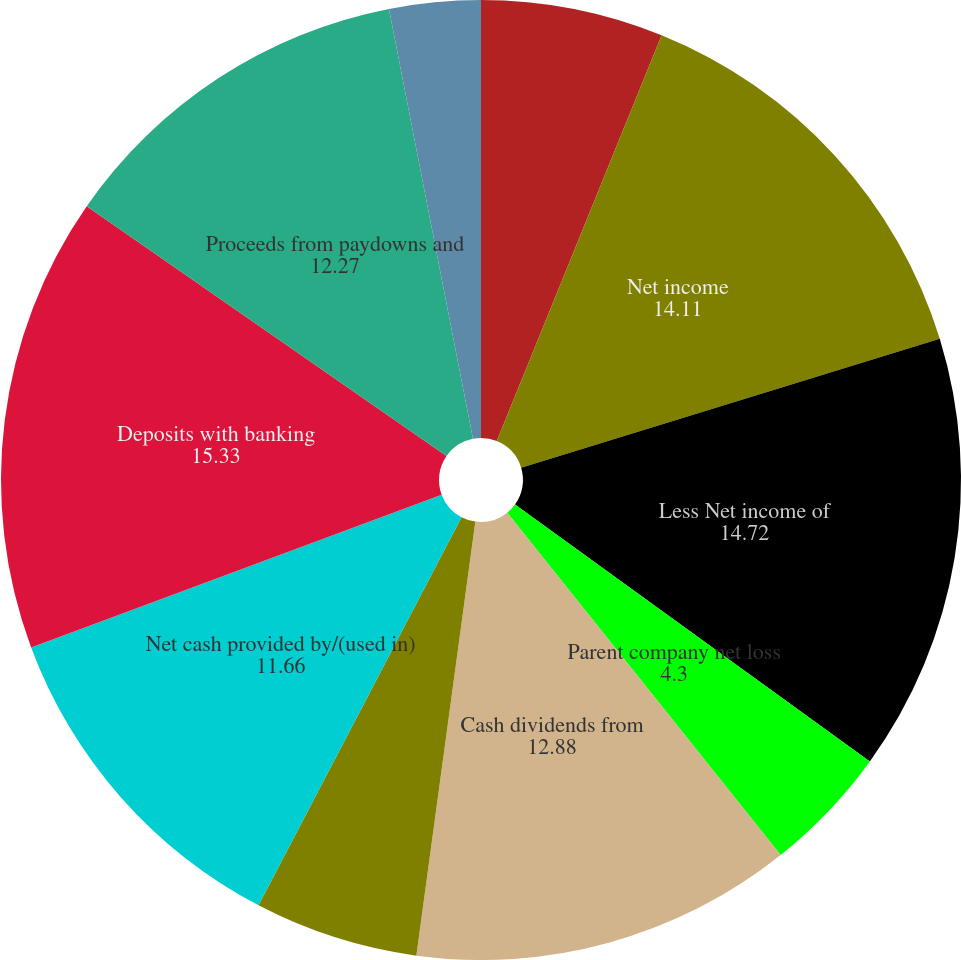Convert chart. <chart><loc_0><loc_0><loc_500><loc_500><pie_chart><fcel>Year ended December 31 (in<fcel>Net income<fcel>Less Net income of<fcel>Parent company net loss<fcel>Cash dividends from<fcel>Other operating adjustments<fcel>Net cash provided by/(used in)<fcel>Deposits with banking<fcel>Proceeds from paydowns and<fcel>Other changes in loans net<nl><fcel>6.14%<fcel>14.11%<fcel>14.72%<fcel>4.3%<fcel>12.88%<fcel>5.52%<fcel>11.66%<fcel>15.33%<fcel>12.27%<fcel>3.07%<nl></chart> 